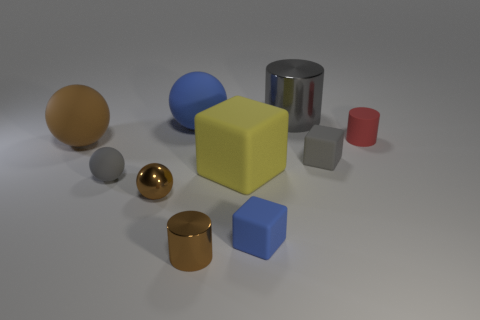Does the large cylinder have the same color as the small matte ball?
Your answer should be compact. Yes. What is the material of the thing that is both in front of the red matte cylinder and to the right of the big gray metal cylinder?
Your response must be concise. Rubber. What size is the gray sphere?
Your answer should be very brief. Small. There is a tiny gray matte ball left of the metal thing behind the yellow cube; how many small brown objects are left of it?
Your answer should be very brief. 0. There is a gray rubber thing that is right of the gray object that is on the left side of the tiny blue thing; what shape is it?
Your answer should be very brief. Cube. The gray thing that is the same shape as the yellow matte thing is what size?
Give a very brief answer. Small. The cylinder in front of the rubber cylinder is what color?
Provide a succinct answer. Brown. What material is the blue ball behind the tiny gray object to the right of the gray matte thing in front of the big yellow block?
Your answer should be compact. Rubber. What size is the metal thing behind the cube to the right of the gray cylinder?
Keep it short and to the point. Large. What color is the other small object that is the same shape as the small red object?
Your response must be concise. Brown. 